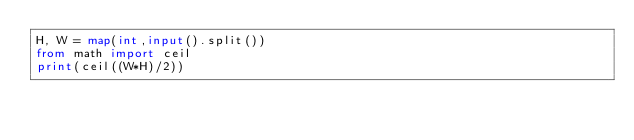Convert code to text. <code><loc_0><loc_0><loc_500><loc_500><_Python_>H, W = map(int,input().split())
from math import ceil
print(ceil((W*H)/2))
</code> 